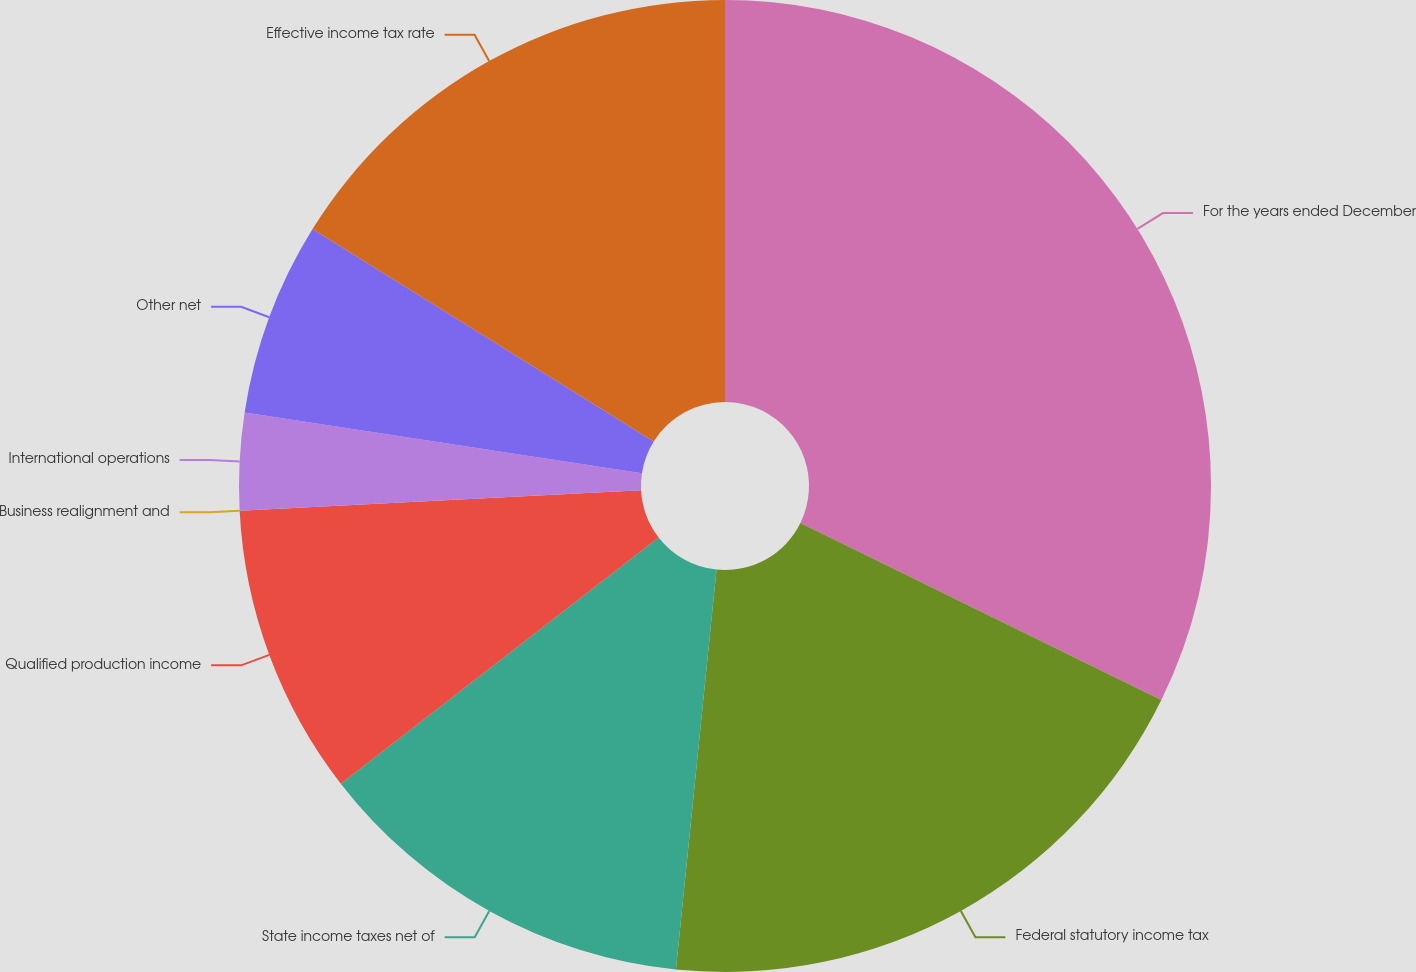Convert chart. <chart><loc_0><loc_0><loc_500><loc_500><pie_chart><fcel>For the years ended December<fcel>Federal statutory income tax<fcel>State income taxes net of<fcel>Qualified production income<fcel>Business realignment and<fcel>International operations<fcel>Other net<fcel>Effective income tax rate<nl><fcel>32.26%<fcel>19.35%<fcel>12.9%<fcel>9.68%<fcel>0.0%<fcel>3.23%<fcel>6.45%<fcel>16.13%<nl></chart> 